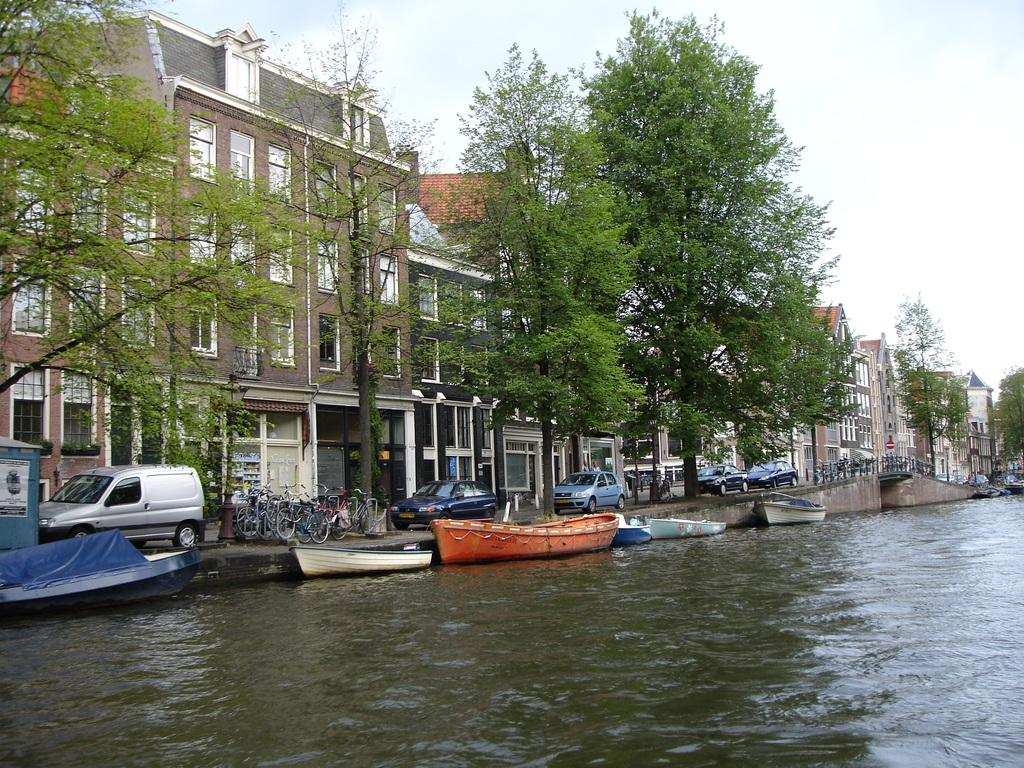What is on the water in the image? There are boats on the water in the image. What can be seen in the background of the image? There are vehicles, trees with green color, and buildings with brown, gray, and cream colors in the background of the image. What is the color of the sky in the image? The sky appears to be white in the image. Can you see the sun in the image? The provided facts do not mention the sun, and there is no indication of the sun in the image. Are there any signs of fear in the image? There is no indication of fear in the image, as it primarily features boats on the water and other elements in the background. 